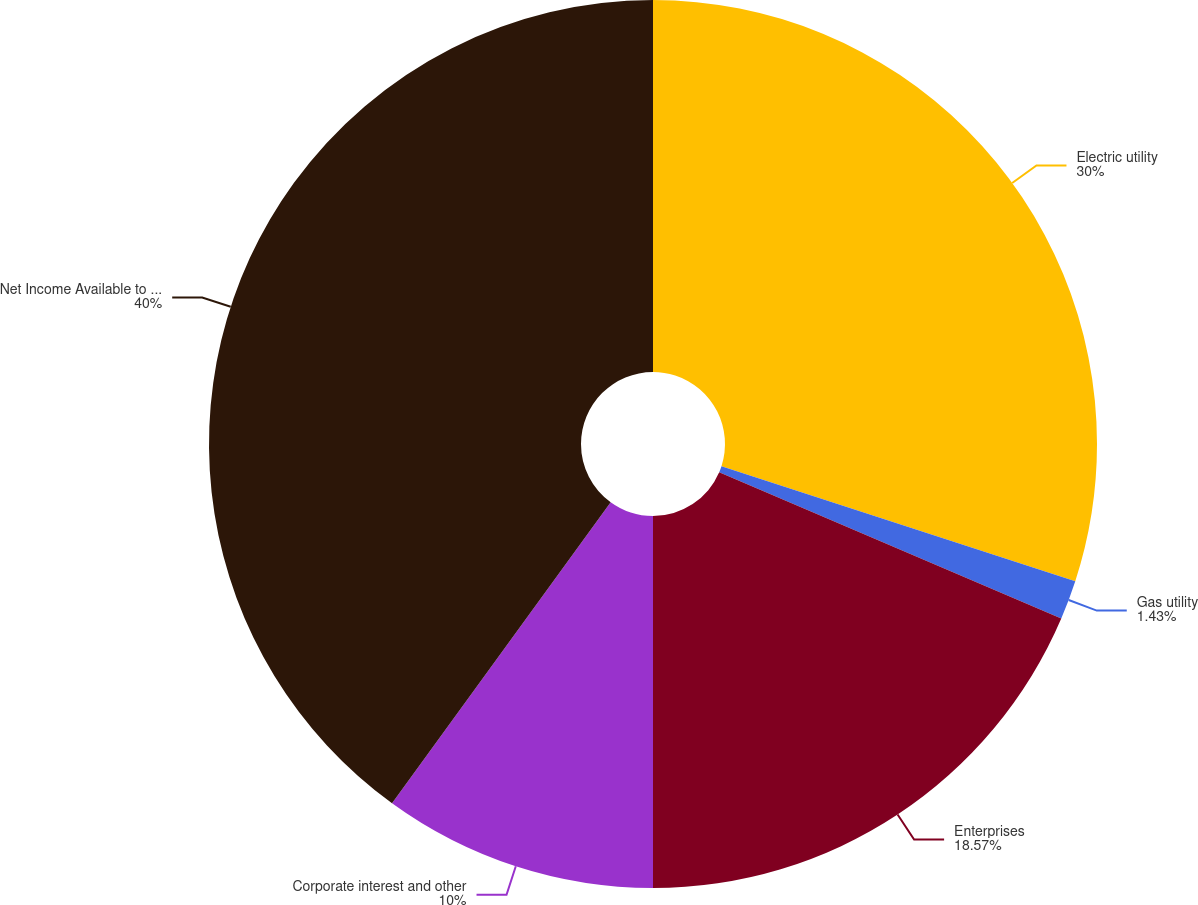Convert chart to OTSL. <chart><loc_0><loc_0><loc_500><loc_500><pie_chart><fcel>Electric utility<fcel>Gas utility<fcel>Enterprises<fcel>Corporate interest and other<fcel>Net Income Available to Common<nl><fcel>30.0%<fcel>1.43%<fcel>18.57%<fcel>10.0%<fcel>40.0%<nl></chart> 